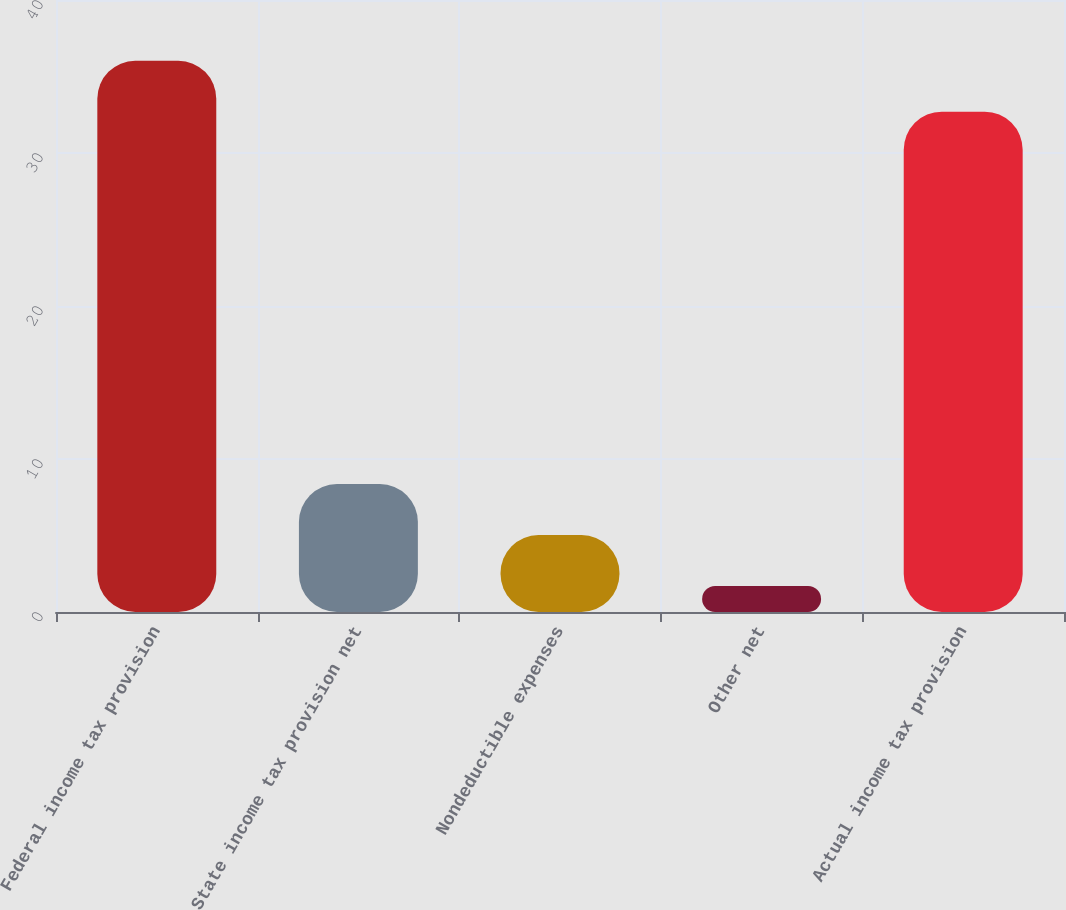Convert chart to OTSL. <chart><loc_0><loc_0><loc_500><loc_500><bar_chart><fcel>Federal income tax provision<fcel>State income tax provision net<fcel>Nondeductible expenses<fcel>Other net<fcel>Actual income tax provision<nl><fcel>36.03<fcel>8.36<fcel>5.03<fcel>1.7<fcel>32.7<nl></chart> 